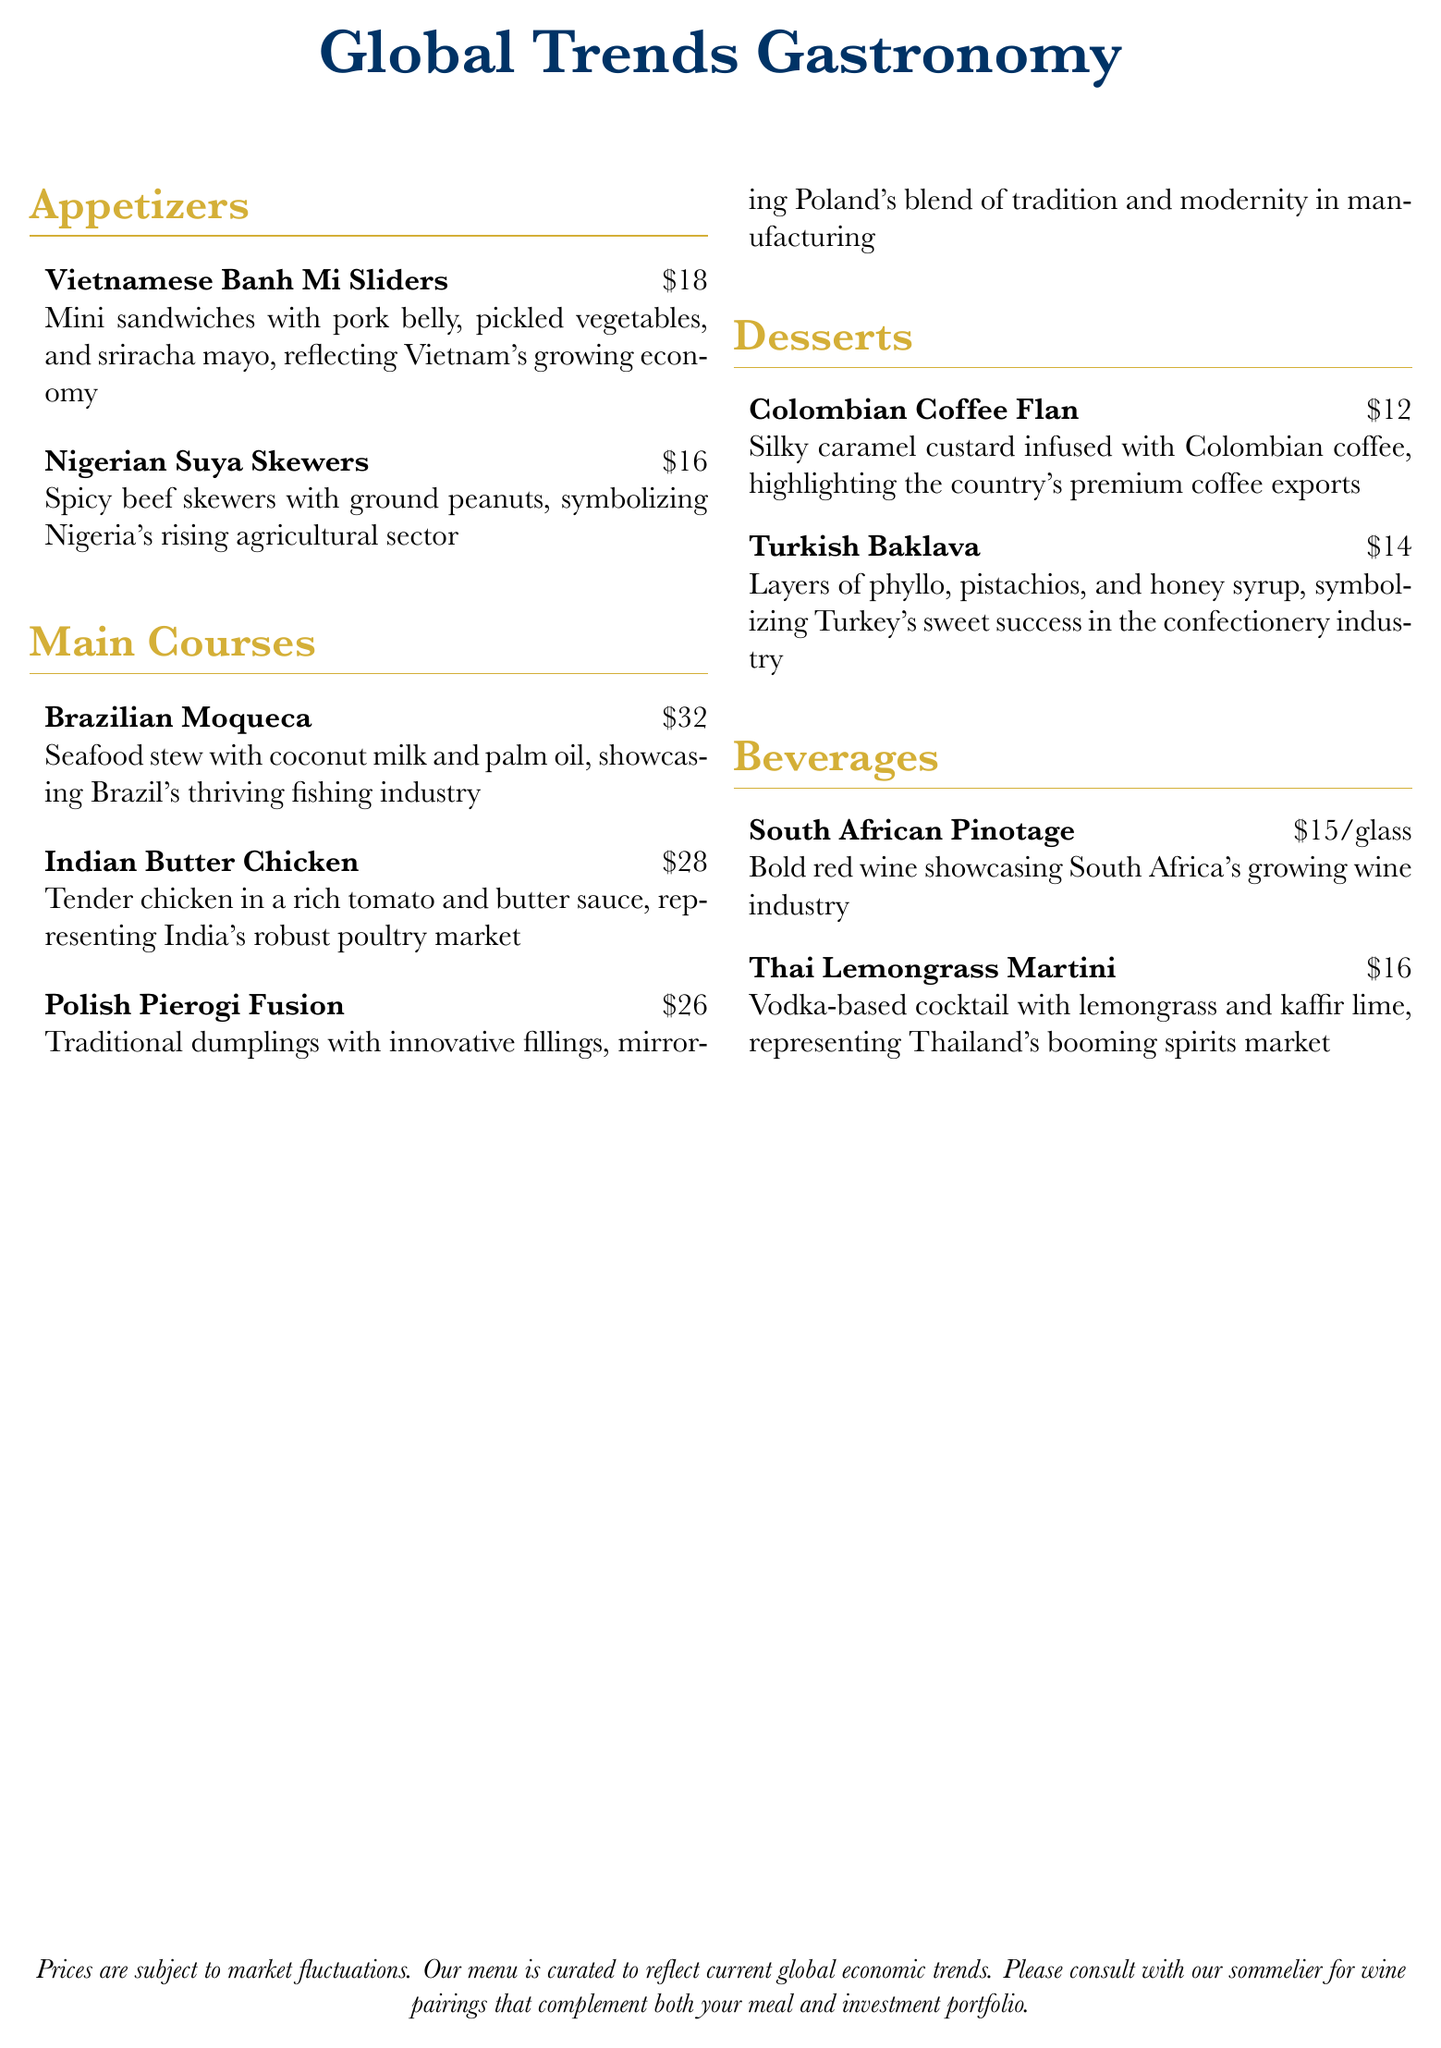What is the price of Vietnamese Banh Mi Sliders? The price is listed next to the dish in the menu.
Answer: $18 What type of meat is used in Nigerian Suya Skewers? The menu specifies the ingredients used in each dish.
Answer: Beef Which dessert highlights Colombia's premium exports? The menu describes each dessert's significance.
Answer: Colombian Coffee Flan What beverage represents Thailand's booming market? The beverage items are linked to their country's industry.
Answer: Thai Lemongrass Martini How many main courses are listed on the menu? The total number of items under the main courses section can be counted.
Answer: 3 What industry does the Brazilian Moqueca showcase? The description of the dish references its background.
Answer: Fishing industry Which country is associated with the sweet confectionery industry? The menu indicates which countries relate to specific industries.
Answer: Turkey What is the main ingredient in Turkish Baklava? The dish description lists key components of the dessert.
Answer: Pistachios 